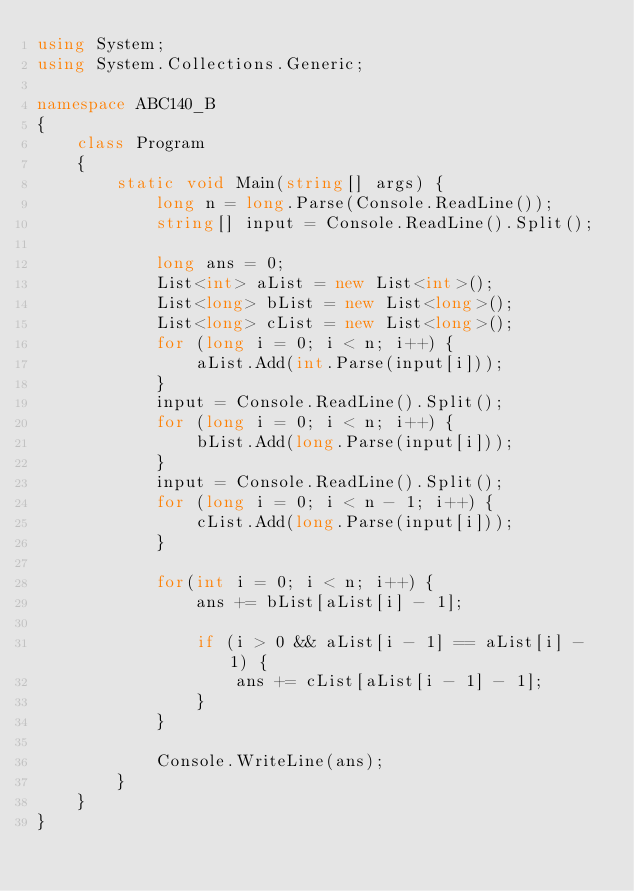Convert code to text. <code><loc_0><loc_0><loc_500><loc_500><_C#_>using System;
using System.Collections.Generic;

namespace ABC140_B
{
    class Program
    {
        static void Main(string[] args) {
            long n = long.Parse(Console.ReadLine());
            string[] input = Console.ReadLine().Split();

            long ans = 0;
            List<int> aList = new List<int>();
            List<long> bList = new List<long>();
            List<long> cList = new List<long>();
            for (long i = 0; i < n; i++) {
                aList.Add(int.Parse(input[i]));
            }
            input = Console.ReadLine().Split();
            for (long i = 0; i < n; i++) {
                bList.Add(long.Parse(input[i]));
            }
            input = Console.ReadLine().Split();
            for (long i = 0; i < n - 1; i++) {
                cList.Add(long.Parse(input[i]));
            }

            for(int i = 0; i < n; i++) {
                ans += bList[aList[i] - 1];

                if (i > 0 && aList[i - 1] == aList[i] - 1) {
                    ans += cList[aList[i - 1] - 1];
                }
            }

            Console.WriteLine(ans);
        }
    }
}</code> 